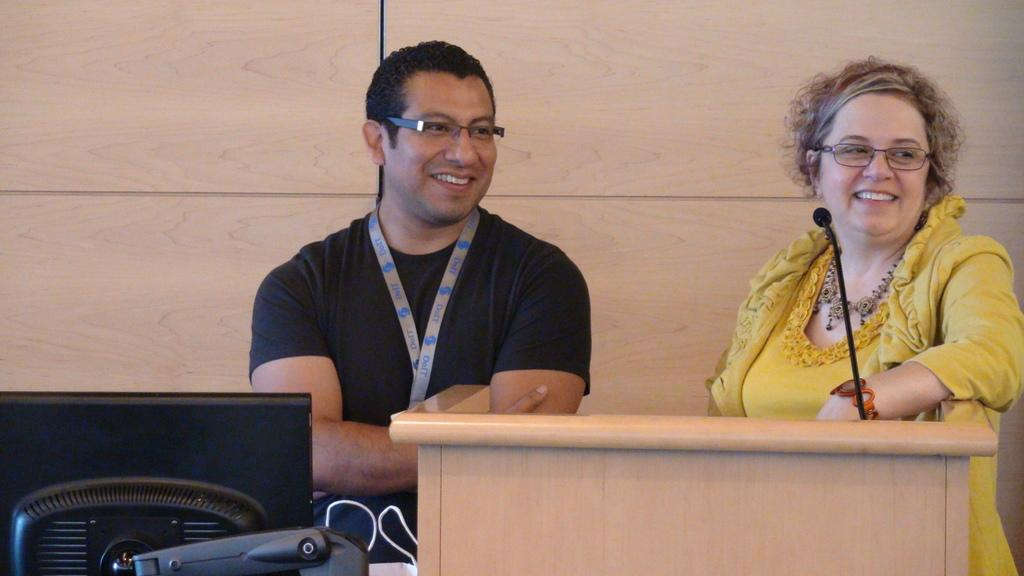How many people are present in the image? There is a man and a woman in the image. What objects can be seen in the image that are related to public speaking? There is a podium, a microphone, and a monitor in the image. What is visible in the background of the image? There is a wall in the background of the image. Can you see a body of water in the image? There is no body of water or any reference to a ship or airplane in the image. 